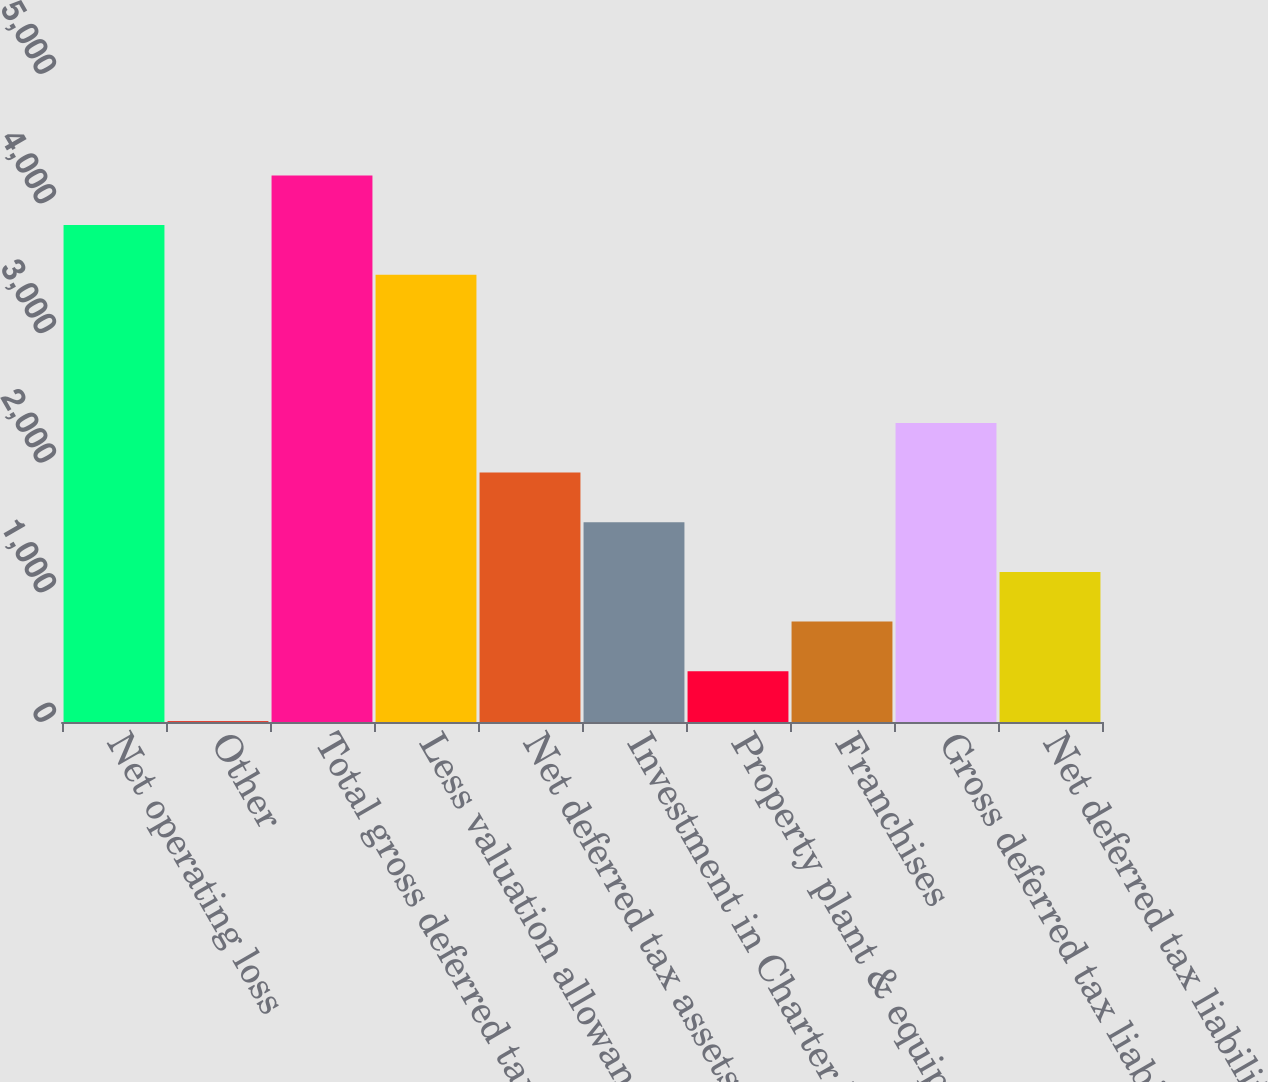Convert chart. <chart><loc_0><loc_0><loc_500><loc_500><bar_chart><fcel>Net operating loss<fcel>Other<fcel>Total gross deferred tax<fcel>Less valuation allowance<fcel>Net deferred tax assets<fcel>Investment in Charter Holdco<fcel>Property plant & equipment<fcel>Franchises<fcel>Gross deferred tax liabilities<fcel>Net deferred tax liabilities<nl><fcel>3834.3<fcel>8<fcel>4217.6<fcel>3451<fcel>1924.5<fcel>1541.2<fcel>391.3<fcel>774.6<fcel>2307.8<fcel>1157.9<nl></chart> 